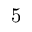Convert formula to latex. <formula><loc_0><loc_0><loc_500><loc_500>5</formula> 